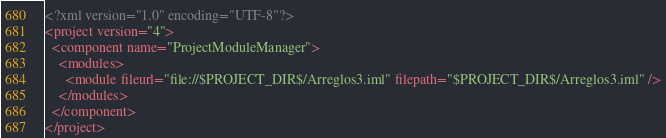Convert code to text. <code><loc_0><loc_0><loc_500><loc_500><_XML_><?xml version="1.0" encoding="UTF-8"?>
<project version="4">
  <component name="ProjectModuleManager">
    <modules>
      <module fileurl="file://$PROJECT_DIR$/Arreglos3.iml" filepath="$PROJECT_DIR$/Arreglos3.iml" />
    </modules>
  </component>
</project></code> 